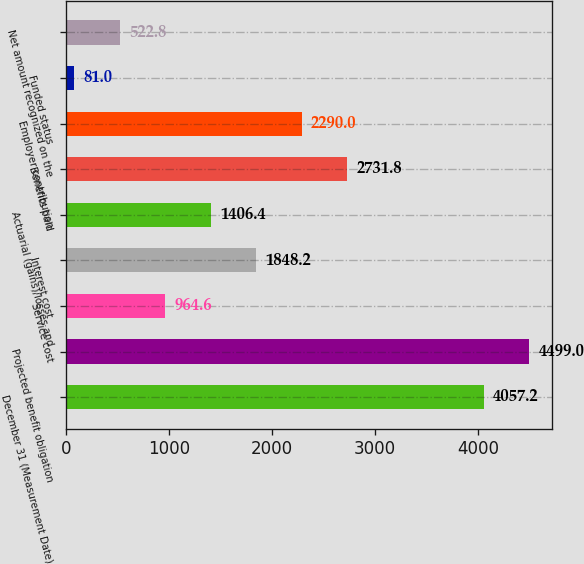<chart> <loc_0><loc_0><loc_500><loc_500><bar_chart><fcel>December 31 (Measurement Date)<fcel>Projected benefit obligation<fcel>Service cost<fcel>Interest cost<fcel>Actuarial (gains)/losses and<fcel>Benefits paid<fcel>Employer contribution<fcel>Funded status<fcel>Net amount recognized on the<nl><fcel>4057.2<fcel>4499<fcel>964.6<fcel>1848.2<fcel>1406.4<fcel>2731.8<fcel>2290<fcel>81<fcel>522.8<nl></chart> 